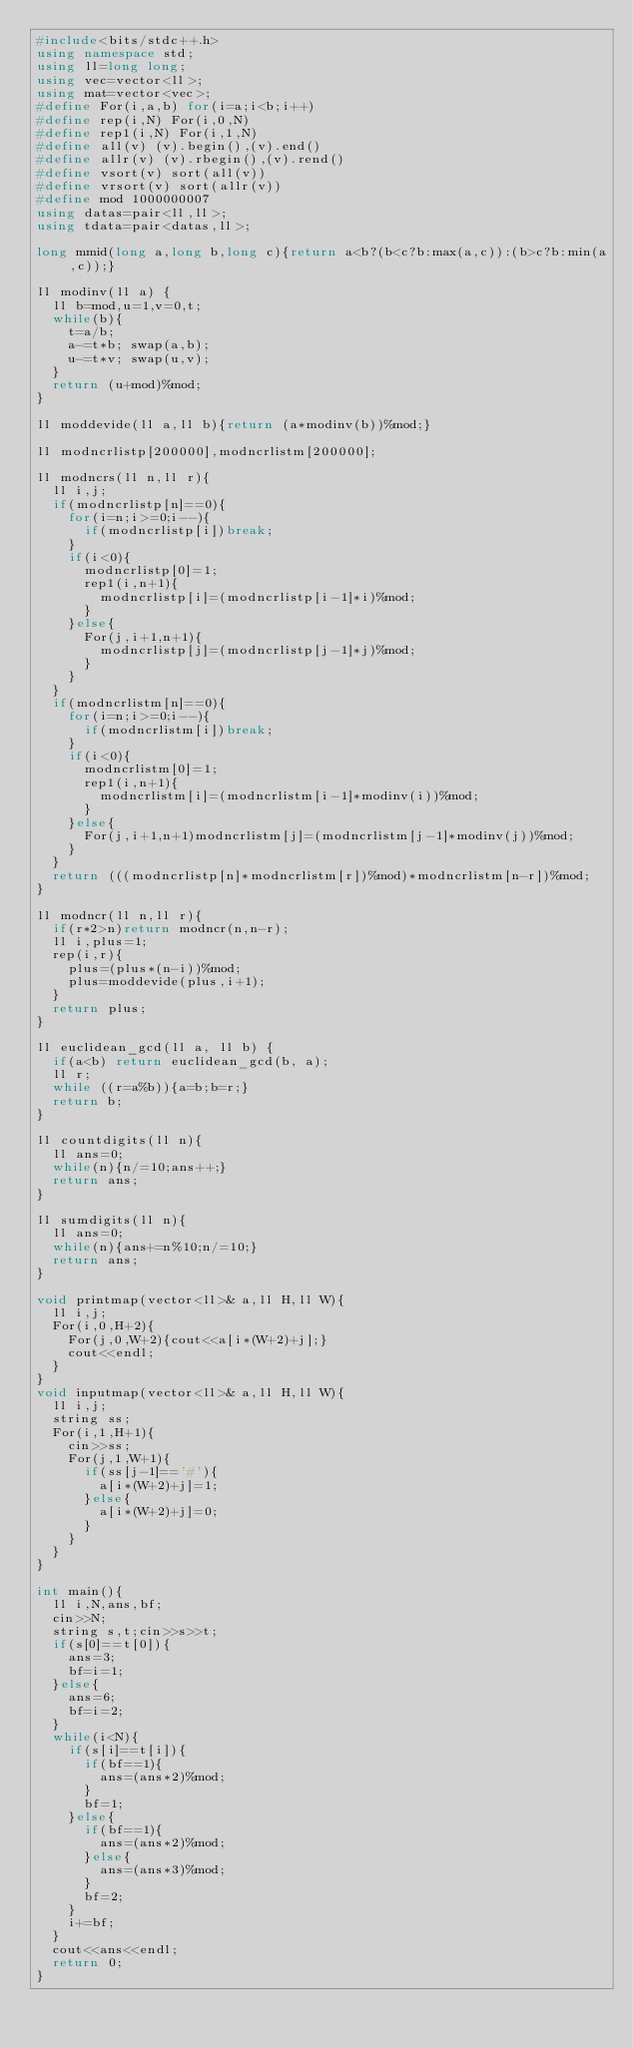<code> <loc_0><loc_0><loc_500><loc_500><_C++_>#include<bits/stdc++.h>
using namespace std;
using ll=long long;
using vec=vector<ll>;
using mat=vector<vec>;
#define For(i,a,b) for(i=a;i<b;i++)
#define rep(i,N) For(i,0,N)
#define rep1(i,N) For(i,1,N)
#define all(v) (v).begin(),(v).end()
#define allr(v) (v).rbegin(),(v).rend()
#define vsort(v) sort(all(v))
#define vrsort(v) sort(allr(v))
#define mod 1000000007
using datas=pair<ll,ll>;
using tdata=pair<datas,ll>;

long mmid(long a,long b,long c){return a<b?(b<c?b:max(a,c)):(b>c?b:min(a,c));}

ll modinv(ll a) {
  ll b=mod,u=1,v=0,t;
  while(b){
    t=a/b;
    a-=t*b; swap(a,b);
    u-=t*v; swap(u,v);
  }
  return (u+mod)%mod;
}

ll moddevide(ll a,ll b){return (a*modinv(b))%mod;}

ll modncrlistp[200000],modncrlistm[200000];

ll modncrs(ll n,ll r){
  ll i,j;
  if(modncrlistp[n]==0){
    for(i=n;i>=0;i--){
      if(modncrlistp[i])break;
    }
    if(i<0){
      modncrlistp[0]=1;
      rep1(i,n+1){
        modncrlistp[i]=(modncrlistp[i-1]*i)%mod;
      }
    }else{
      For(j,i+1,n+1){
        modncrlistp[j]=(modncrlistp[j-1]*j)%mod;
      }
    }
  }
  if(modncrlistm[n]==0){
    for(i=n;i>=0;i--){
      if(modncrlistm[i])break;
    }
    if(i<0){
      modncrlistm[0]=1;
      rep1(i,n+1){
        modncrlistm[i]=(modncrlistm[i-1]*modinv(i))%mod;
      }
    }else{
      For(j,i+1,n+1)modncrlistm[j]=(modncrlistm[j-1]*modinv(j))%mod;
    }
  }
  return (((modncrlistp[n]*modncrlistm[r])%mod)*modncrlistm[n-r])%mod;
}

ll modncr(ll n,ll r){
  if(r*2>n)return modncr(n,n-r);
  ll i,plus=1;
  rep(i,r){
    plus=(plus*(n-i))%mod;
    plus=moddevide(plus,i+1);
  }
  return plus;
}

ll euclidean_gcd(ll a, ll b) {
  if(a<b) return euclidean_gcd(b, a);
  ll r;
  while ((r=a%b)){a=b;b=r;}
  return b;
}

ll countdigits(ll n){
  ll ans=0;
  while(n){n/=10;ans++;}
  return ans;
}

ll sumdigits(ll n){
  ll ans=0;
  while(n){ans+=n%10;n/=10;}
  return ans;
}

void printmap(vector<ll>& a,ll H,ll W){
  ll i,j;
  For(i,0,H+2){
    For(j,0,W+2){cout<<a[i*(W+2)+j];}
    cout<<endl;
  }
}
void inputmap(vector<ll>& a,ll H,ll W){
  ll i,j;
  string ss;
  For(i,1,H+1){
    cin>>ss;
    For(j,1,W+1){
      if(ss[j-1]=='#'){
        a[i*(W+2)+j]=1;
      }else{
        a[i*(W+2)+j]=0;
      }
    }
  }
}

int main(){
  ll i,N,ans,bf;
  cin>>N;
  string s,t;cin>>s>>t;
  if(s[0]==t[0]){
    ans=3;
    bf=i=1;
  }else{
    ans=6;
    bf=i=2;
  }
  while(i<N){
    if(s[i]==t[i]){
      if(bf==1){
        ans=(ans*2)%mod;
      }
      bf=1;
    }else{
      if(bf==1){
        ans=(ans*2)%mod;
      }else{
        ans=(ans*3)%mod;
      }
      bf=2;
    }
    i+=bf;
  }
  cout<<ans<<endl;
  return 0;
}
</code> 